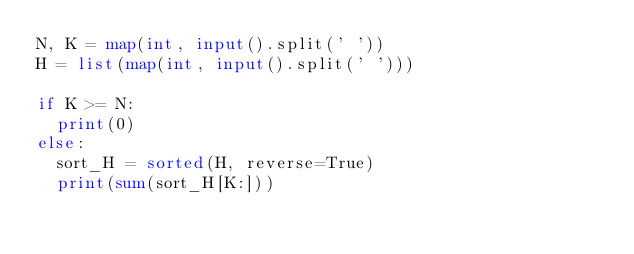Convert code to text. <code><loc_0><loc_0><loc_500><loc_500><_Python_>N, K = map(int, input().split(' '))
H = list(map(int, input().split(' ')))

if K >= N:
  print(0)
else:
  sort_H = sorted(H, reverse=True)
  print(sum(sort_H[K:]))</code> 